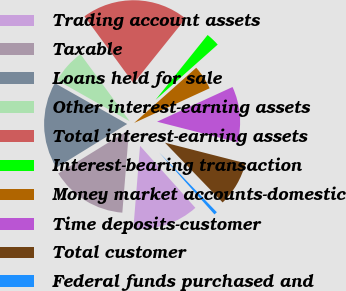Convert chart. <chart><loc_0><loc_0><loc_500><loc_500><pie_chart><fcel>Trading account assets<fcel>Taxable<fcel>Loans held for sale<fcel>Other interest-earning assets<fcel>Total interest-earning assets<fcel>Interest-bearing transaction<fcel>Money market accounts-domestic<fcel>Time deposits-customer<fcel>Total customer<fcel>Federal funds purchased and<nl><fcel>12.88%<fcel>14.93%<fcel>16.97%<fcel>6.75%<fcel>20.83%<fcel>2.67%<fcel>4.71%<fcel>10.84%<fcel>8.8%<fcel>0.62%<nl></chart> 